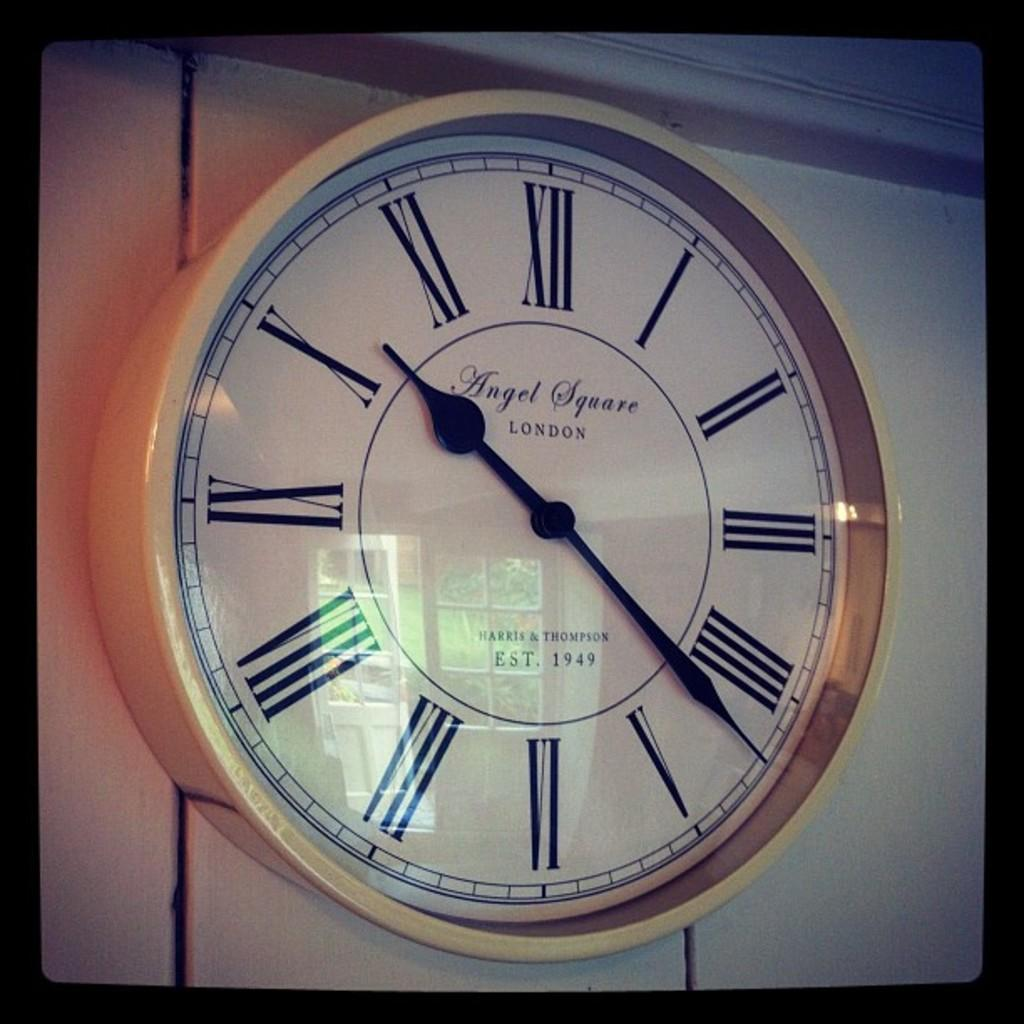<image>
Give a short and clear explanation of the subsequent image. Clock with roman numeral numbers which say "Angel Square" on the front. 